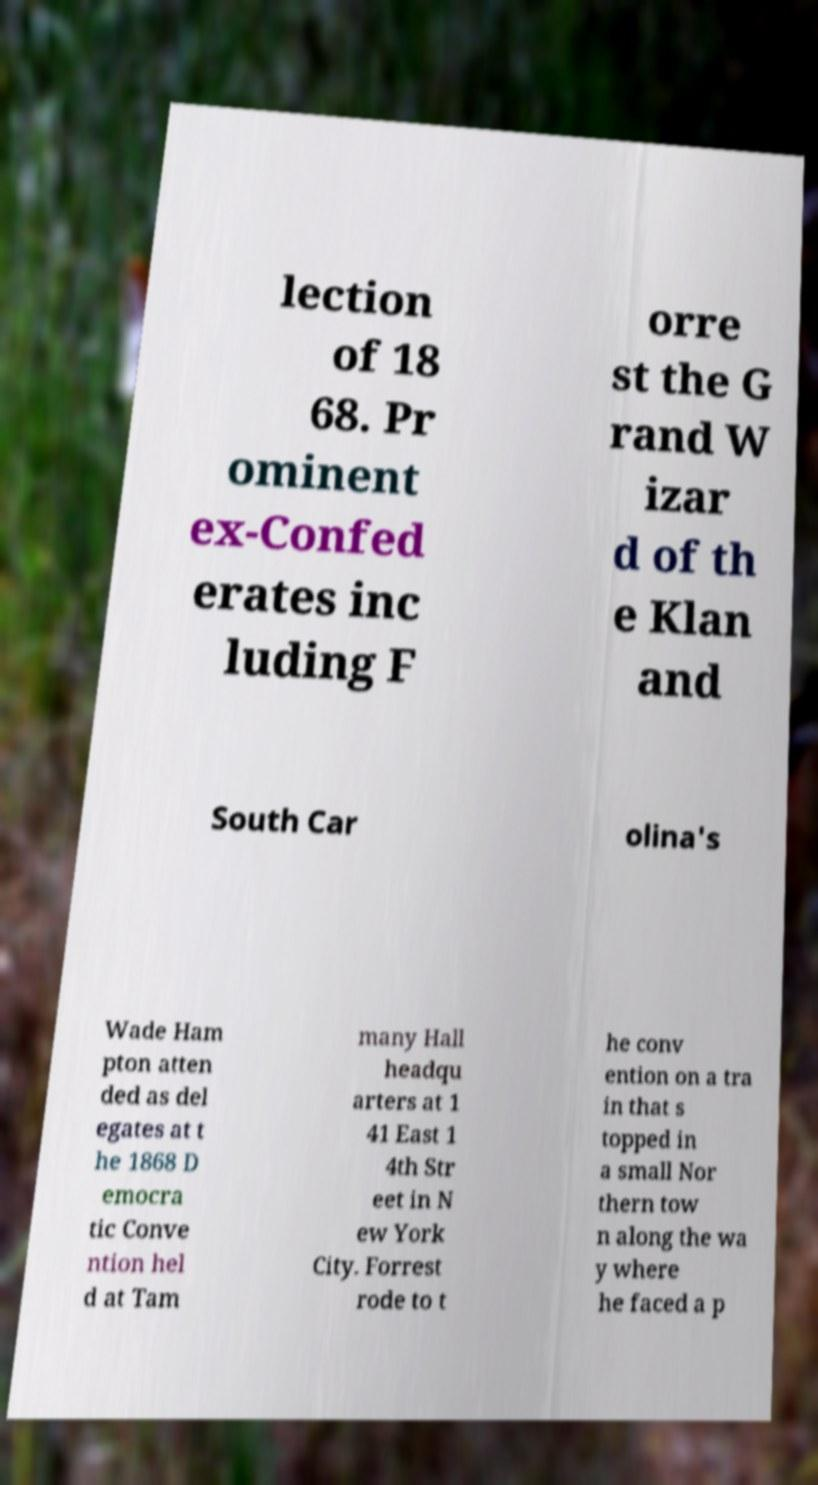Could you extract and type out the text from this image? lection of 18 68. Pr ominent ex-Confed erates inc luding F orre st the G rand W izar d of th e Klan and South Car olina's Wade Ham pton atten ded as del egates at t he 1868 D emocra tic Conve ntion hel d at Tam many Hall headqu arters at 1 41 East 1 4th Str eet in N ew York City. Forrest rode to t he conv ention on a tra in that s topped in a small Nor thern tow n along the wa y where he faced a p 